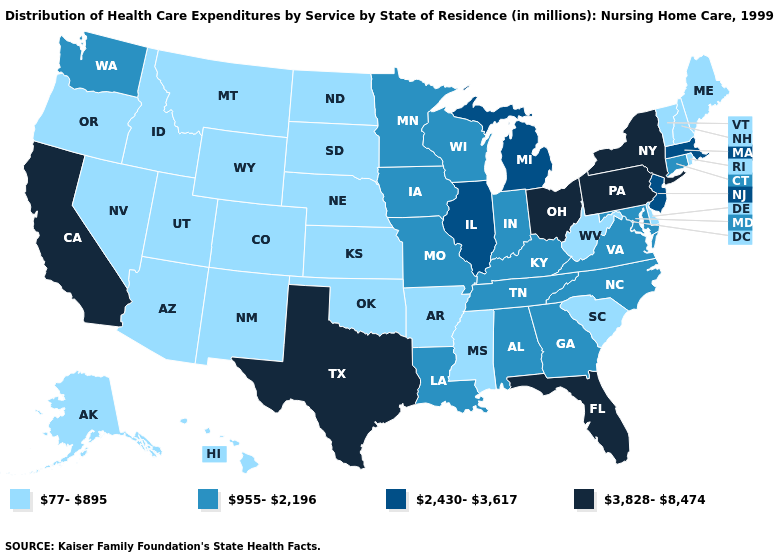Is the legend a continuous bar?
Quick response, please. No. What is the value of Kansas?
Concise answer only. 77-895. Name the states that have a value in the range 2,430-3,617?
Be succinct. Illinois, Massachusetts, Michigan, New Jersey. What is the value of Wisconsin?
Write a very short answer. 955-2,196. Does Massachusetts have the lowest value in the Northeast?
Be succinct. No. Name the states that have a value in the range 77-895?
Answer briefly. Alaska, Arizona, Arkansas, Colorado, Delaware, Hawaii, Idaho, Kansas, Maine, Mississippi, Montana, Nebraska, Nevada, New Hampshire, New Mexico, North Dakota, Oklahoma, Oregon, Rhode Island, South Carolina, South Dakota, Utah, Vermont, West Virginia, Wyoming. What is the lowest value in states that border Kansas?
Concise answer only. 77-895. Does the first symbol in the legend represent the smallest category?
Short answer required. Yes. Name the states that have a value in the range 77-895?
Write a very short answer. Alaska, Arizona, Arkansas, Colorado, Delaware, Hawaii, Idaho, Kansas, Maine, Mississippi, Montana, Nebraska, Nevada, New Hampshire, New Mexico, North Dakota, Oklahoma, Oregon, Rhode Island, South Carolina, South Dakota, Utah, Vermont, West Virginia, Wyoming. Which states have the lowest value in the MidWest?
Give a very brief answer. Kansas, Nebraska, North Dakota, South Dakota. Name the states that have a value in the range 3,828-8,474?
Short answer required. California, Florida, New York, Ohio, Pennsylvania, Texas. Which states have the lowest value in the USA?
Give a very brief answer. Alaska, Arizona, Arkansas, Colorado, Delaware, Hawaii, Idaho, Kansas, Maine, Mississippi, Montana, Nebraska, Nevada, New Hampshire, New Mexico, North Dakota, Oklahoma, Oregon, Rhode Island, South Carolina, South Dakota, Utah, Vermont, West Virginia, Wyoming. Does West Virginia have the lowest value in the USA?
Concise answer only. Yes. Name the states that have a value in the range 77-895?
Concise answer only. Alaska, Arizona, Arkansas, Colorado, Delaware, Hawaii, Idaho, Kansas, Maine, Mississippi, Montana, Nebraska, Nevada, New Hampshire, New Mexico, North Dakota, Oklahoma, Oregon, Rhode Island, South Carolina, South Dakota, Utah, Vermont, West Virginia, Wyoming. 